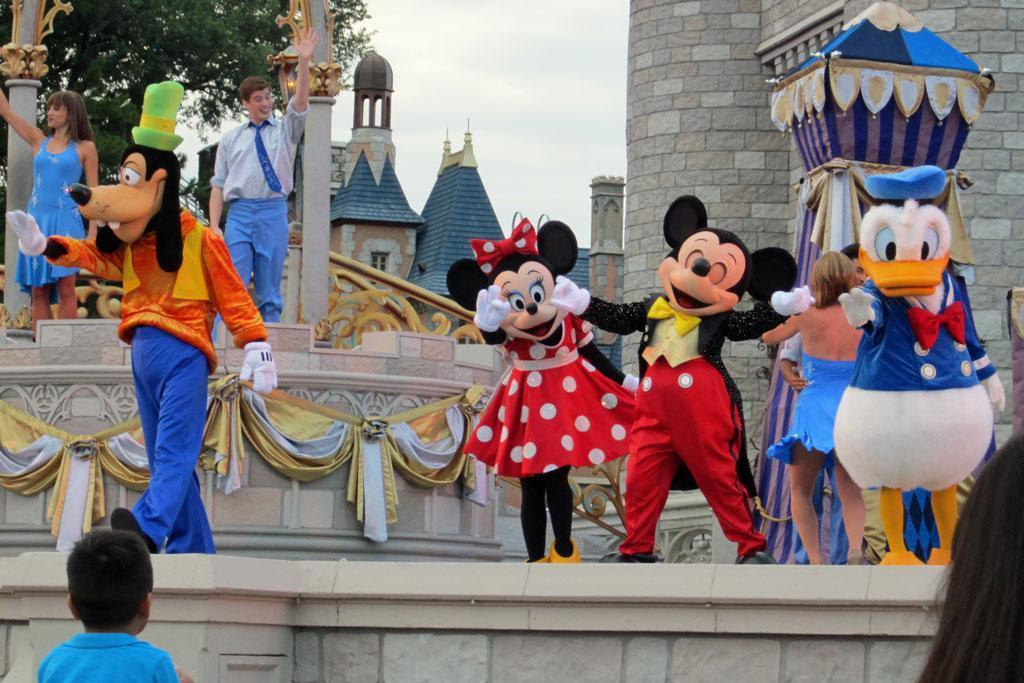Describe this image in one or two sentences. There are people and these people are wore costumes. We can see tent,walls,pillars and curtains. In the background we can see trees,buildings and sky. 